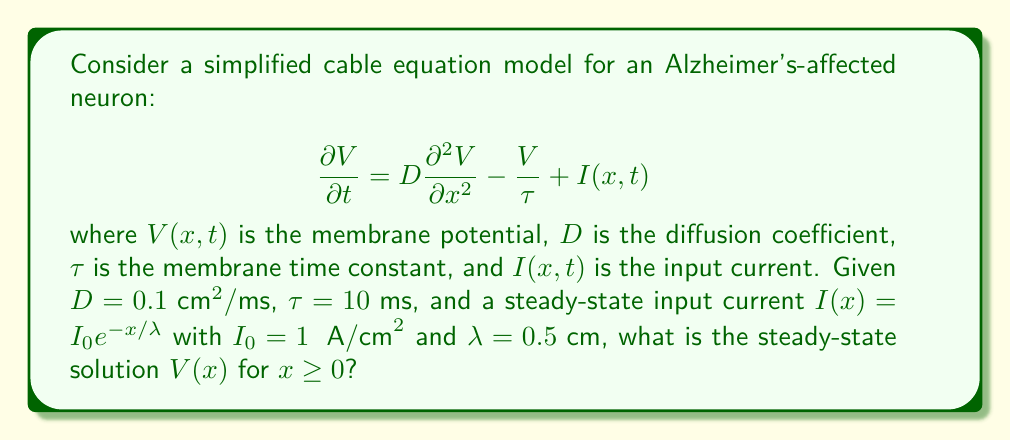Can you solve this math problem? To solve this problem, we'll follow these steps:

1) For the steady-state solution, $\frac{\partial V}{\partial t} = 0$, so our equation becomes:

   $$D \frac{d^2 V}{dx^2} - \frac{V}{\tau} + I_0 e^{-x/\lambda} = 0$$

2) This is a non-homogeneous second-order ODE. The general solution will be the sum of the homogeneous solution and a particular solution.

3) For the homogeneous part $D \frac{d^2 V}{dx^2} - \frac{V}{\tau} = 0$, we assume a solution of the form $V = e^{mx}$. Substituting:

   $$Dm^2 - \frac{1}{\tau} = 0$$

   $$m = \pm \sqrt{\frac{1}{D\tau}} = \pm \frac{1}{\sqrt{D\tau}}$$

4) The homogeneous solution is thus:

   $$V_h(x) = A e^{x/\sqrt{D\tau}} + B e^{-x/\sqrt{D\tau}}$$

5) For the particular solution, we try $V_p(x) = C e^{-x/\lambda}$. Substituting into the original equation:

   $$D(\frac{1}{\lambda^2})C e^{-x/\lambda} - \frac{C}{\tau} e^{-x/\lambda} + I_0 e^{-x/\lambda} = 0$$

   $$C(\frac{D}{\lambda^2} - \frac{1}{\tau}) = -I_0$$

   $$C = \frac{-I_0}{\frac{D}{\lambda^2} - \frac{1}{\tau}}$$

6) The general solution is $V(x) = V_h(x) + V_p(x)$:

   $$V(x) = A e^{x/\sqrt{D\tau}} + B e^{-x/\sqrt{D\tau}} + \frac{-I_0}{\frac{D}{\lambda^2} - \frac{1}{\tau}} e^{-x/\lambda}$$

7) For a bounded solution as $x \to \infty$, we must have $A = 0$. To determine $B$, we use the boundary condition $V(0) = 0$:

   $$0 = B + \frac{-I_0}{\frac{D}{\lambda^2} - \frac{1}{\tau}}$$

   $$B = \frac{I_0}{\frac{D}{\lambda^2} - \frac{1}{\tau}}$$

8) Substituting the given values:

   $$V(x) = \frac{1}{\frac{0.1}{0.5^2} - \frac{1}{10}} (e^{-x/\sqrt{0.1 \cdot 10}} - e^{-x/0.5})$$

   $$= 2.5 (e^{-x} - e^{-2x}) \text{ μV}$$

This is the steady-state solution for $x \geq 0$.
Answer: $V(x) = 2.5 (e^{-x} - e^{-2x}) \text{ μV}$ for $x \geq 0$ 